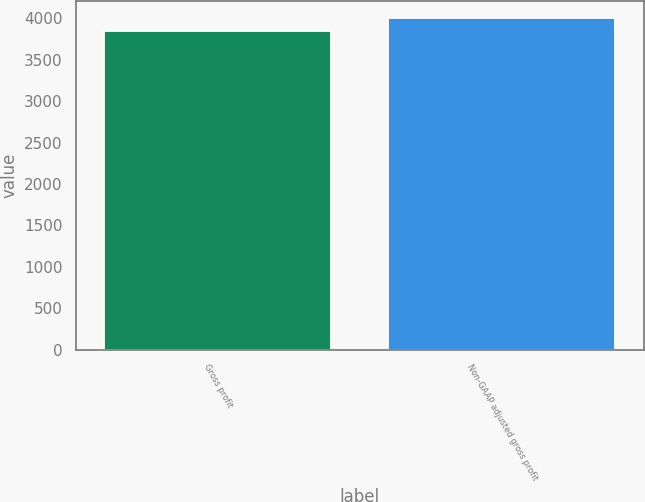Convert chart. <chart><loc_0><loc_0><loc_500><loc_500><bar_chart><fcel>Gross profit<fcel>Non-GAAP adjusted gross profit<nl><fcel>3843<fcel>4002<nl></chart> 